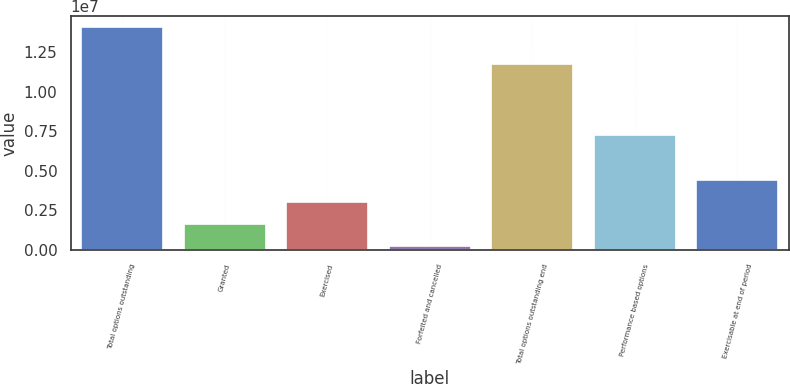Convert chart. <chart><loc_0><loc_0><loc_500><loc_500><bar_chart><fcel>Total options outstanding<fcel>Granted<fcel>Exercised<fcel>Forfeited and cancelled<fcel>Total options outstanding end<fcel>Performance based options<fcel>Exercisable at end of period<nl><fcel>1.40586e+07<fcel>1.65444e+06<fcel>3.03267e+06<fcel>276200<fcel>1.17258e+07<fcel>7.2465e+06<fcel>4.41091e+06<nl></chart> 